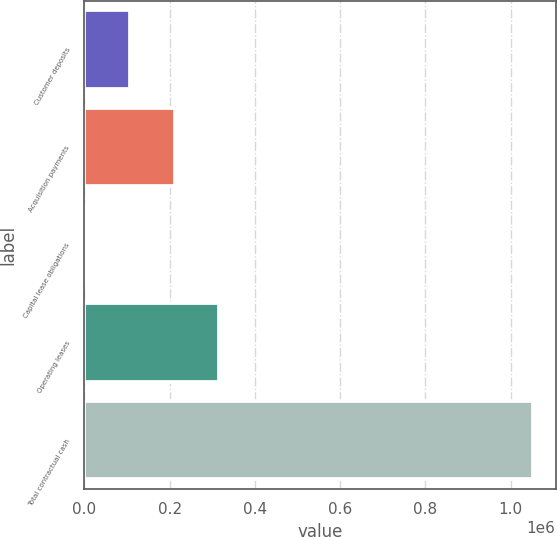Convert chart to OTSL. <chart><loc_0><loc_0><loc_500><loc_500><bar_chart><fcel>Customer deposits<fcel>Acquisition payments<fcel>Capital lease obligations<fcel>Operating leases<fcel>Total contractual cash<nl><fcel>106566<fcel>211720<fcel>1411<fcel>316875<fcel>1.05296e+06<nl></chart> 